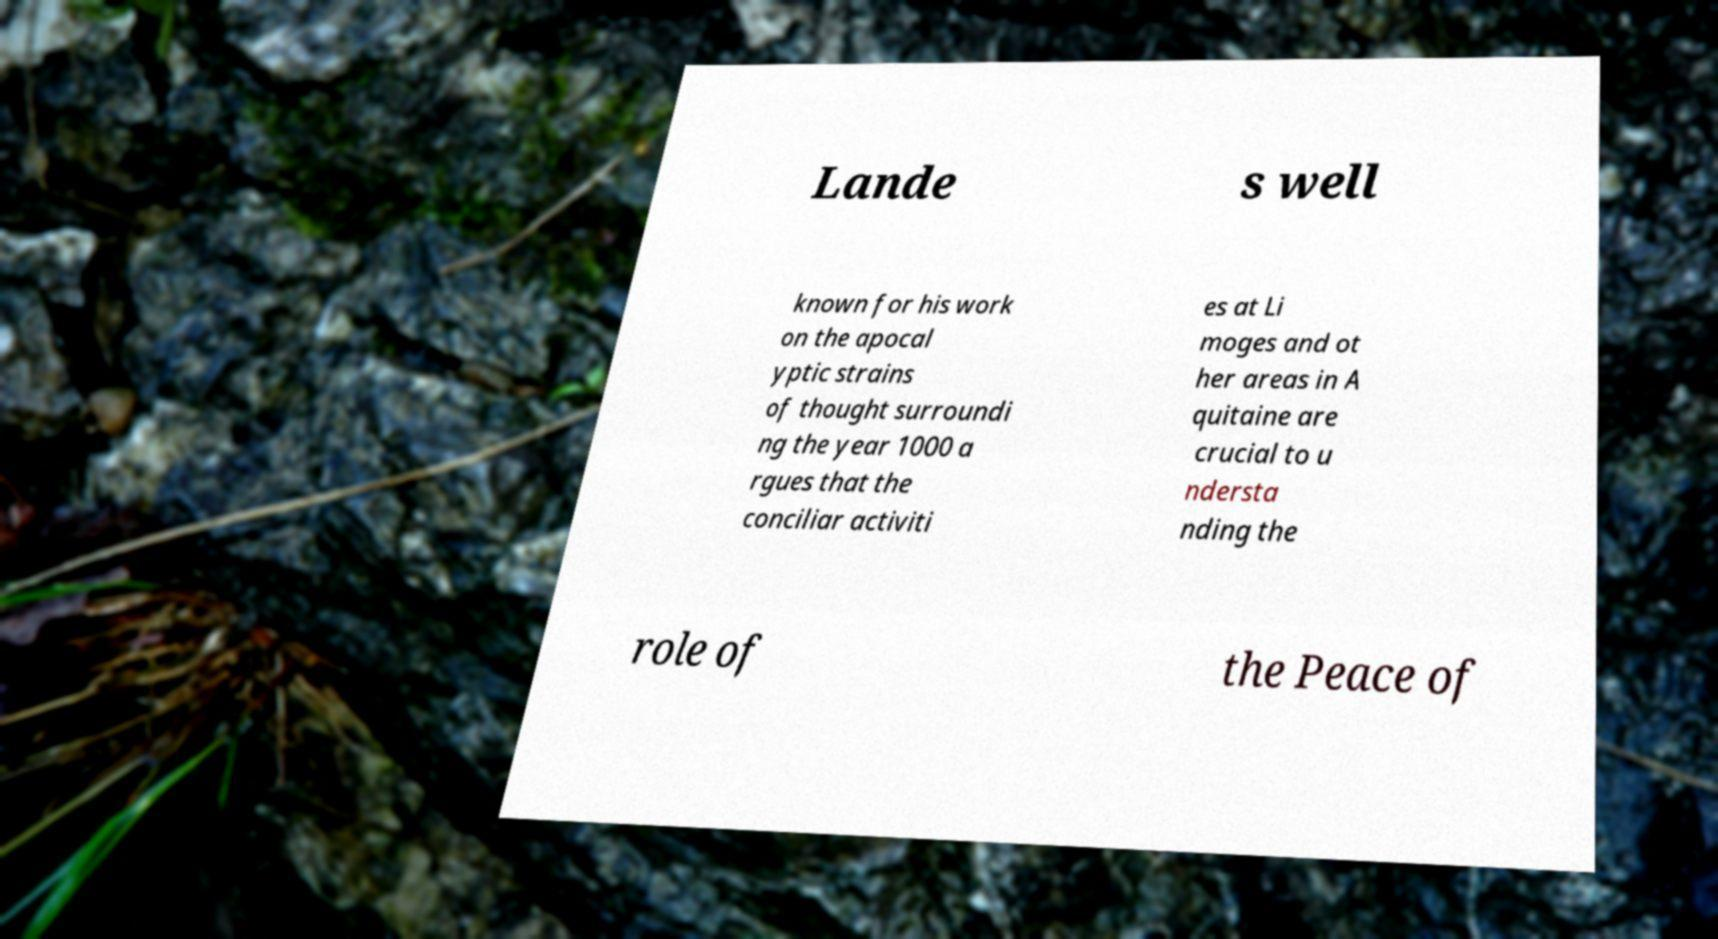For documentation purposes, I need the text within this image transcribed. Could you provide that? Lande s well known for his work on the apocal yptic strains of thought surroundi ng the year 1000 a rgues that the conciliar activiti es at Li moges and ot her areas in A quitaine are crucial to u ndersta nding the role of the Peace of 